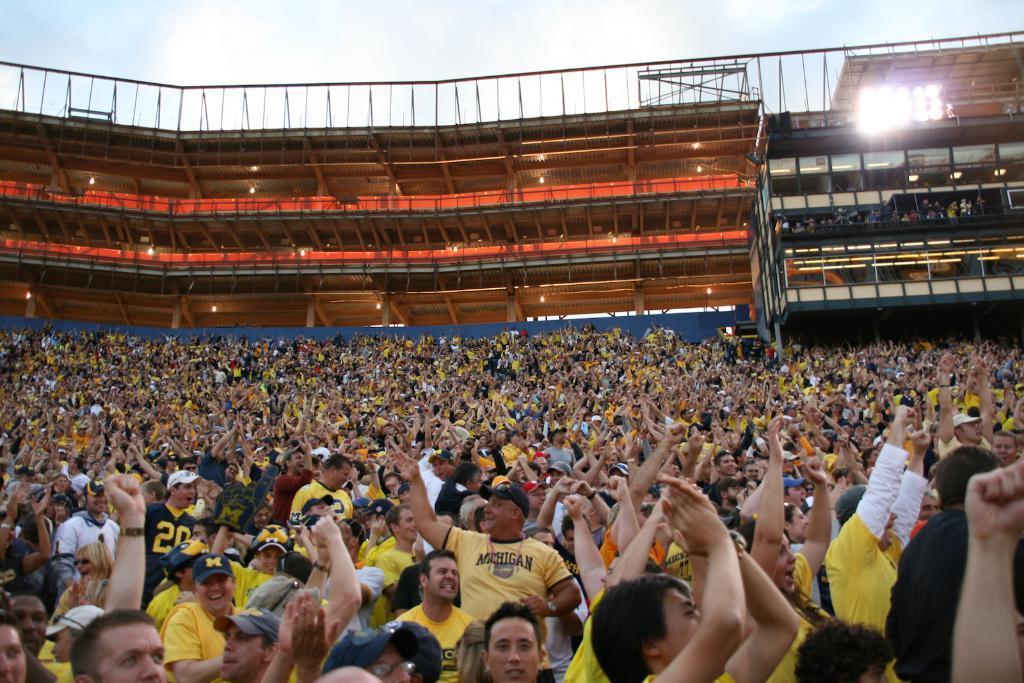Could you give a brief overview of what you see in this image? There are groups of people standing. I think this is a stadium. These look like buildings. Here is the sky. 